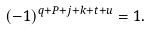<formula> <loc_0><loc_0><loc_500><loc_500>( - 1 ) ^ { q + P + j + k + t + u } = 1 .</formula> 